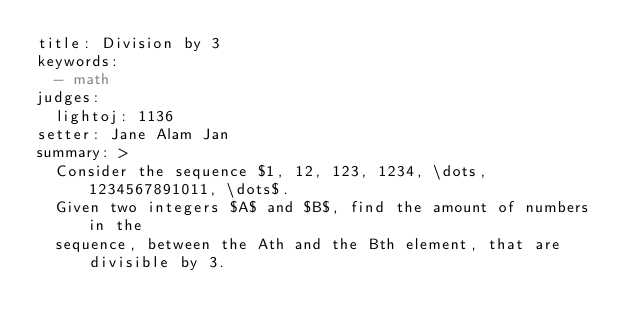Convert code to text. <code><loc_0><loc_0><loc_500><loc_500><_YAML_>title: Division by 3
keywords:
  - math
judges:
  lightoj: 1136
setter: Jane Alam Jan
summary: >
  Consider the sequence $1, 12, 123, 1234, \dots, 1234567891011, \dots$.
  Given two integers $A$ and $B$, find the amount of numbers in the
  sequence, between the Ath and the Bth element, that are divisible by 3.
</code> 